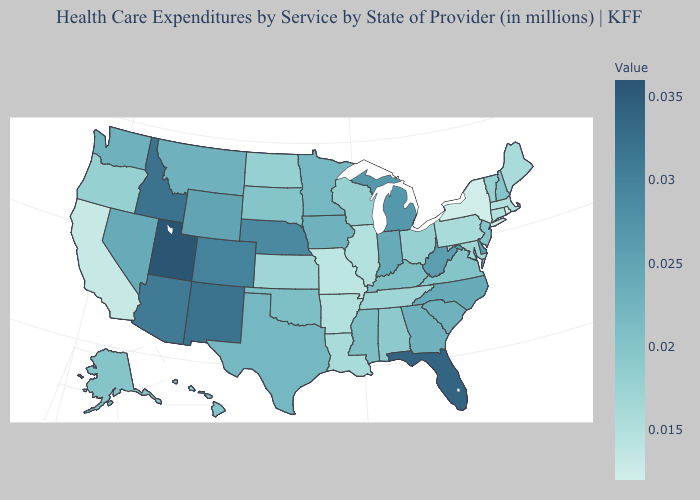Does Maryland have a lower value than Florida?
Short answer required. Yes. Does Utah have the highest value in the USA?
Concise answer only. Yes. Does Colorado have the highest value in the West?
Write a very short answer. No. 